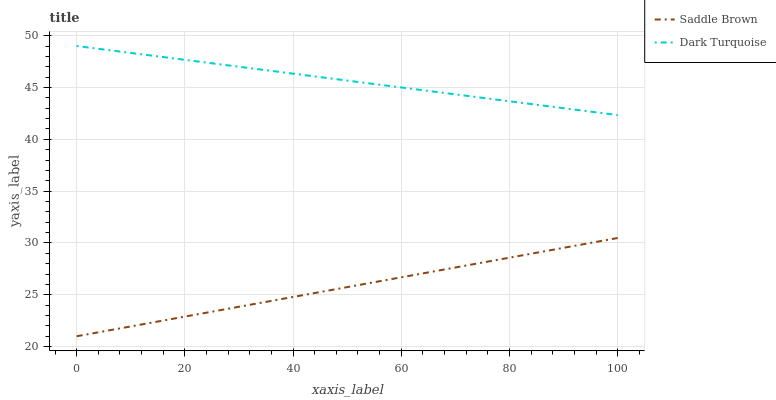Does Saddle Brown have the minimum area under the curve?
Answer yes or no. Yes. Does Dark Turquoise have the maximum area under the curve?
Answer yes or no. Yes. Does Saddle Brown have the maximum area under the curve?
Answer yes or no. No. Is Saddle Brown the smoothest?
Answer yes or no. Yes. Is Dark Turquoise the roughest?
Answer yes or no. Yes. Is Saddle Brown the roughest?
Answer yes or no. No. Does Saddle Brown have the lowest value?
Answer yes or no. Yes. Does Dark Turquoise have the highest value?
Answer yes or no. Yes. Does Saddle Brown have the highest value?
Answer yes or no. No. Is Saddle Brown less than Dark Turquoise?
Answer yes or no. Yes. Is Dark Turquoise greater than Saddle Brown?
Answer yes or no. Yes. Does Saddle Brown intersect Dark Turquoise?
Answer yes or no. No. 